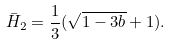<formula> <loc_0><loc_0><loc_500><loc_500>\bar { H } _ { 2 } = \frac { 1 } { 3 } ( \sqrt { 1 - 3 b } + 1 ) .</formula> 